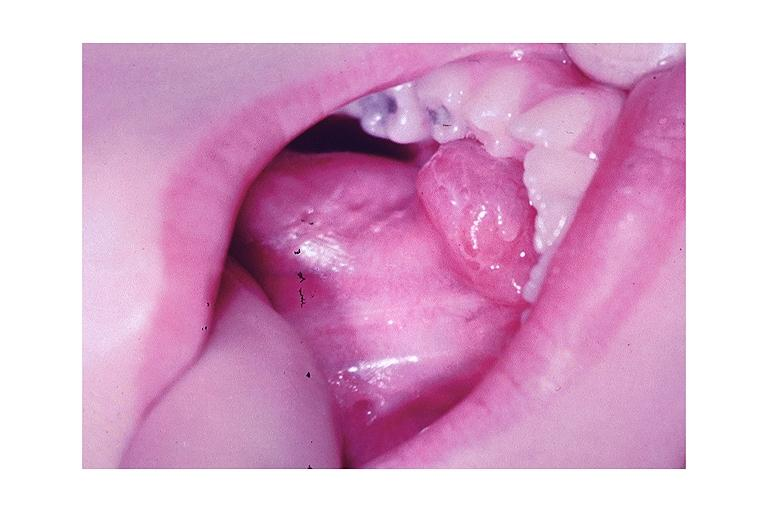does metastatic colon carcinoma show ranula?
Answer the question using a single word or phrase. No 